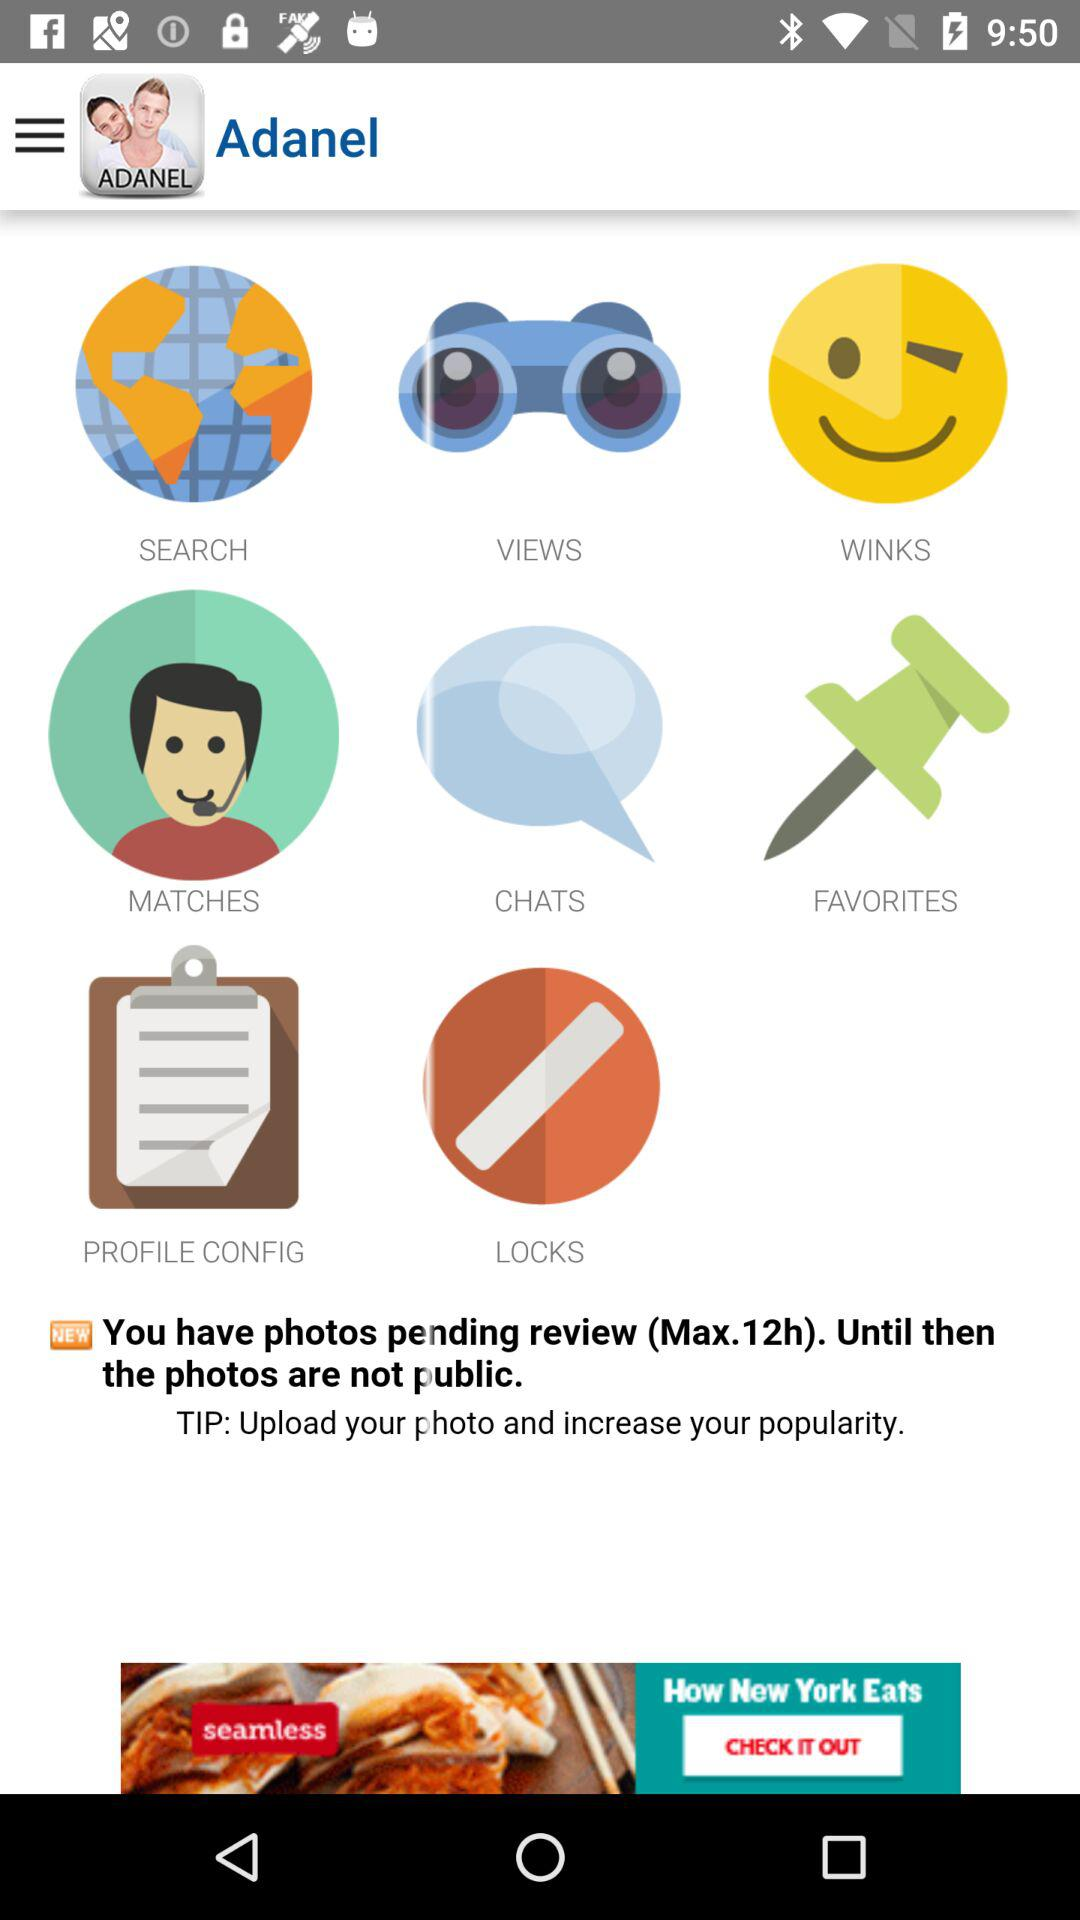What is the name of the application? The name of the application is "Adanel". 